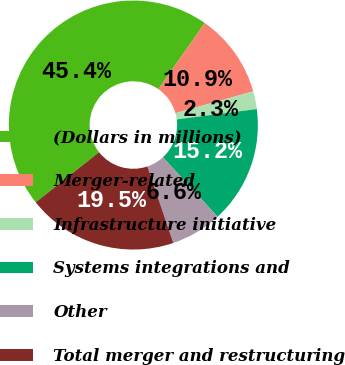Convert chart to OTSL. <chart><loc_0><loc_0><loc_500><loc_500><pie_chart><fcel>(Dollars in millions)<fcel>Merger-related<fcel>Infrastructure initiative<fcel>Systems integrations and<fcel>Other<fcel>Total merger and restructuring<nl><fcel>45.38%<fcel>10.92%<fcel>2.31%<fcel>15.23%<fcel>6.62%<fcel>19.54%<nl></chart> 